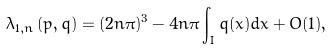Convert formula to latex. <formula><loc_0><loc_0><loc_500><loc_500>\lambda _ { 1 , n } \left ( p , q \right ) = ( 2 n \pi ) ^ { 3 } - 4 n \pi \int _ { I } q ( x ) d x + O ( 1 ) ,</formula> 